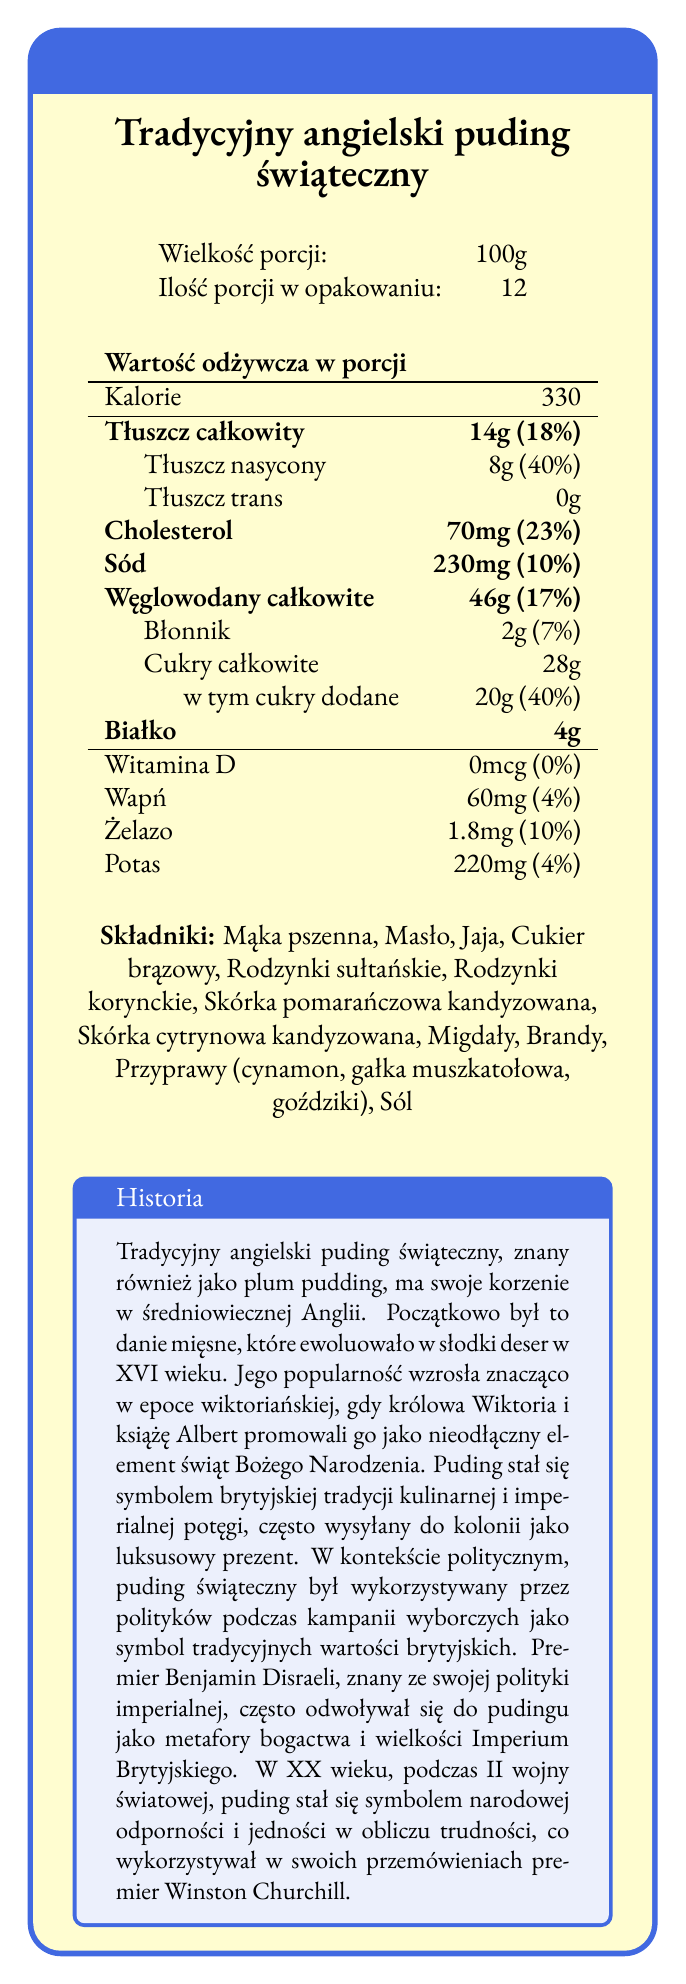what is the serving size? The document specifies that the serving size for the pudding is 100 grams.
Answer: 100g how many servings are there per container? The document indicates that there are 12 servings per container.
Answer: 12 what is the total fat content per serving? Under the nutrition facts, it states that the total fat content per serving is 14 grams.
Answer: 14g how much cholesterol is there per serving? The document lists the cholesterol content as 70 milligrams per serving.
Answer: 70mg list all the ingredients present in the pudding The document provides a detailed list of all the ingredients under the "Składniki" section.
Answer: Mąka pszenna, Masło, Jaja, Cukier brązowy, Rodzynki sułtańskie, Rodzynki korynckie, Skórka pomarańczowa kandyzowana, Skórka cytrynowa kandyzowana, Migdały, Brandy, Przyprawy (cynamon, gałka muszkatołowa, goździki), Sól what percentage of daily value of saturated fat does one serving provide? The document shows that one serving provides 40% of the daily value for saturated fat.
Answer: 40% how much added sugar is in one serving? According to the document, one serving contains 20 grams of added sugars.
Answer: 20g what is the historical origin of the traditional English Christmas pudding? A. Middle Ages B. Renaissance C. Victorian Era The historical description in the document states that the traditional English Christmas pudding has its roots in medieval England.
Answer: A who promoted the pudding as an essential element of Christmas during the Victorian era? A. Queen Victoria and Prince Albert B. King George and Queen Mary C. Prince Charles and Princess Diana The document specifies that Queen Victoria and Prince Albert promoted the pudding during the Victorian era.
Answer: A how many grams of protein are there in one serving? The document lists the protein content in one serving as 4 grams.
Answer: 4g true or false: the traditional English Christmas pudding initially was a meat dish The document indicates that the pudding initially was a meat dish before evolving into a sweet dessert.
Answer: True briefly summarize the main points covered in the document The summary captures the essence of the document by mentioning the key nutritional information, ingredients, and the historical context.
Answer: The document presents the nutrition facts label for a traditional English Christmas pudding, providing details such as the serving size, calories, and nutrient content per serving. It also includes a list of ingredients and a historical description, highlighting the pudding's origins in medieval England, its evolution into a sweet dish, and its cultural and political significance over the centuries. what is the potas amount in each serving? The document states that each serving contains 220 milligrams of potassium.
Answer: 220mg how was the Christmas pudding used politically during Benjamin Disraeli's era? The historical description notes that Prime Minister Benjamin Disraeli used the Christmas pudding as a metaphor for the wealth and greatness of the British Empire.
Answer: As a metaphor for the wealth and greatness of the British Empire can the vitamin D content in one serving be determined from the document provided? The document clearly shows that the vitamin D content in one serving is 0 micrograms.
Answer: Yes, it is 0mcg how many calories are there in one serving? The document specifies that one serving contains 330 calories.
Answer: 330 what is the carbohydrate content per serving? The document states that there are 46 grams of carbohydrates per serving.
Answer: 46g what historical event made the pudding a symbol of national resilience? According to the historical description, the pudding became a symbol of national resilience during World War II.
Answer: World War II how much dietary fiber is in a serving? The document specifies that there are 2 grams of dietary fiber in one serving.
Answer: 2g who frequently referred to the Christmas pudding in speeches to symbolize national unity? The document mentions that Winston Churchill used the Christmas pudding symbolically in his speeches to represent national unity.
Answer: Winston Churchill 